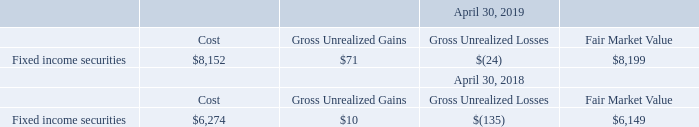8. Marketable Securities
The cost, gross unrealized gains, gross unrealized losses and fair market value of available-for-sale securities at April 30, 2019 and 2018, respectively, were as follows (in thousands):
What is the cost of the fixed income securities in 2019 and 2018 respectively?
Answer scale should be: thousand. $8,152, $6,274. What is the gross unrealized gains of the fixed income securities in 2019 and 2018 respectively?
Answer scale should be: thousand. $71, $10. What does the table show? The cost, gross unrealized gains, gross unrealized losses and fair market value of available-for-sale securities at april 30, 2019 and 2018, respectively. What is the difference in cost of the fixed income securities between 2018 and 2019?
Answer scale should be: thousand. 8,152-6,274
Answer: 1878. What is the percentage change in the fair market value between 2018 and 2019?
Answer scale should be: percent. (8,199-6,149)/6,149
Answer: 33.34. What is the average fair market value for 2018 and 2019?
Answer scale should be: thousand. (8,199+6,149)/2
Answer: 7174. 